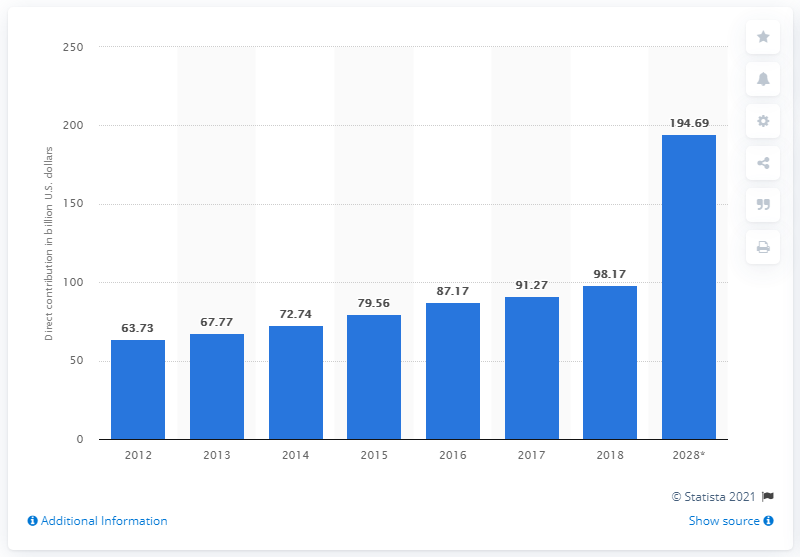Outline some significant characteristics in this image. In 2018, the direct contribution of the travel and tourism sector to India's Gross Domestic Product (GDP) was 98.17%. The forecast for India's GDP by 2028 was 194.69. 